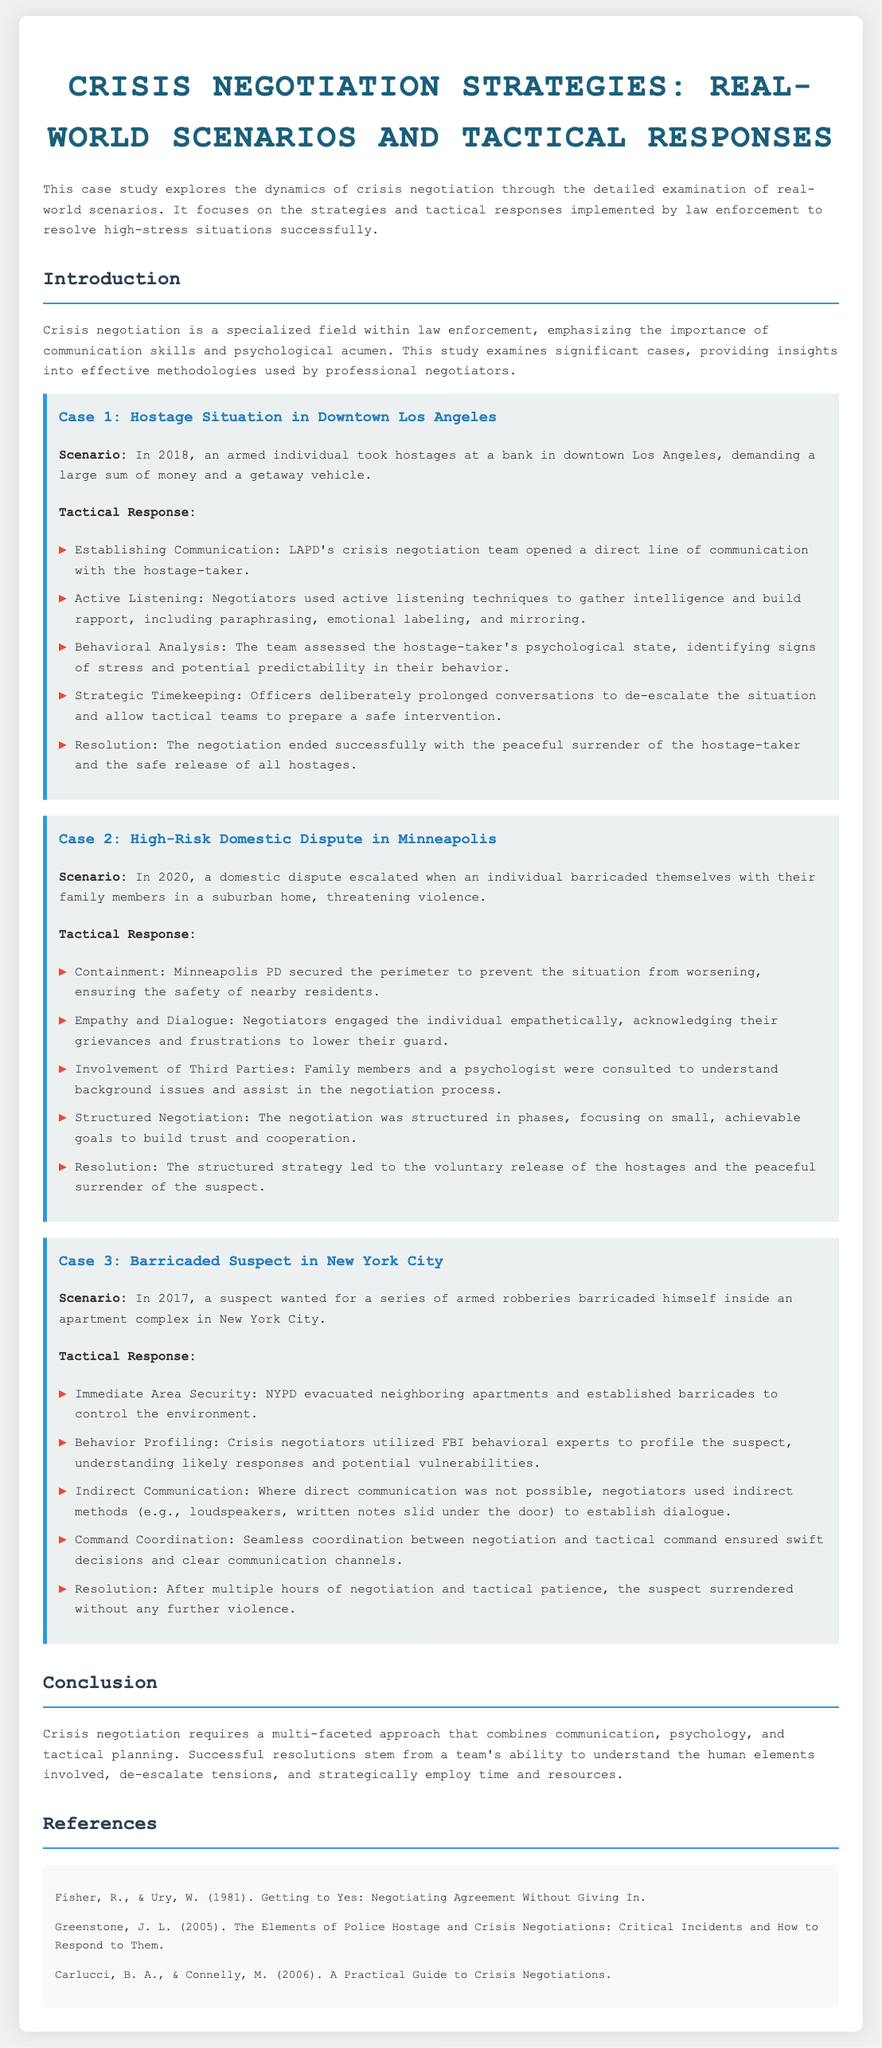What year did the hostage situation in Los Angeles occur? The document states that the hostage situation in downtown Los Angeles occurred in 2018.
Answer: 2018 What was the primary strategy used by negotiators in the Minneapolis case? The primary strategy mentioned for the high-risk domestic dispute was empathy and dialogue to lower the individual's guard.
Answer: Empathy and dialogue How did the NYPD ensure immediate area security during the barricaded suspect case? The document notes that the NYPD evacuated neighboring apartments and established barricades to control the environment.
Answer: Evacuated neighboring apartments What type of analysis did the LAPD perform on the hostage-taker? LAPD performed behavioral analysis to assess the hostage-taker’s psychological state and predict their behavior.
Answer: Behavioral analysis What tactic was used when direct communication was not possible in the New York City case? The negotiators used indirect communication methods like loudspeakers and written notes to establish dialogue.
Answer: Indirect communication What was the outcome of the negotiation in the hostage situation case? The outcome of the negotiation in the hostage situation was the peaceful surrender of the hostage-taker and the safe release of all hostages.
Answer: Peaceful surrender Who were involved in the negotiation process during the Minneapolis domestic dispute? Family members and a psychologist were consulted to understand background issues and assist in the negotiation process.
Answer: Family members and a psychologist What crucial element is emphasized for crisis negotiation according to the conclusion? The conclusion emphasizes the importance of communication as a crucial element for crisis negotiation.
Answer: Communication 